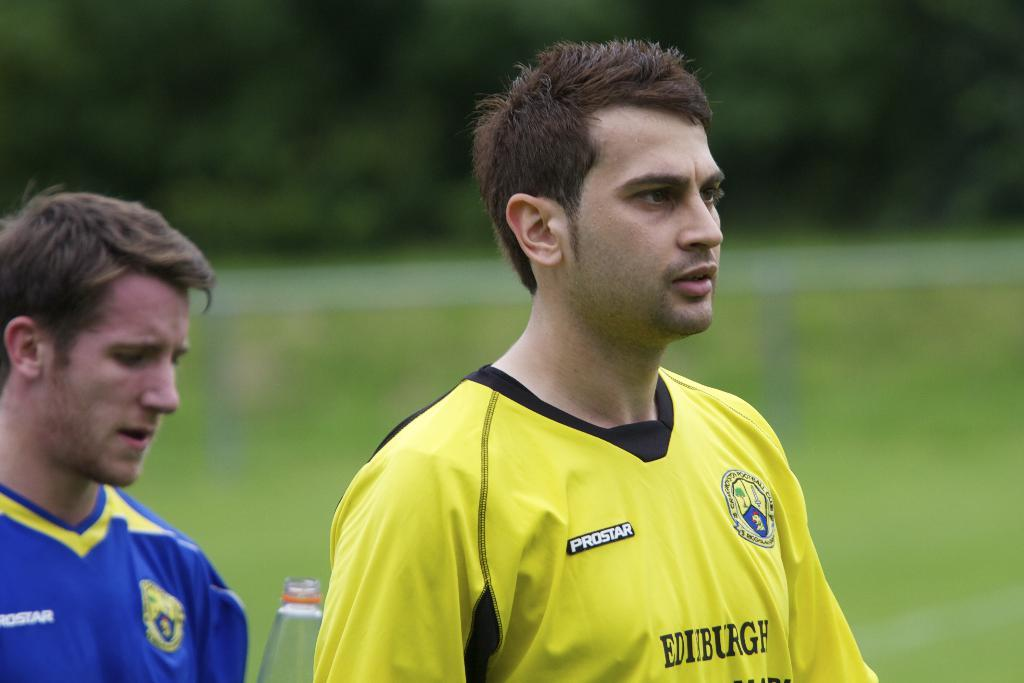Provide a one-sentence caption for the provided image. two soccer players from opposing teams in the prostar league. 